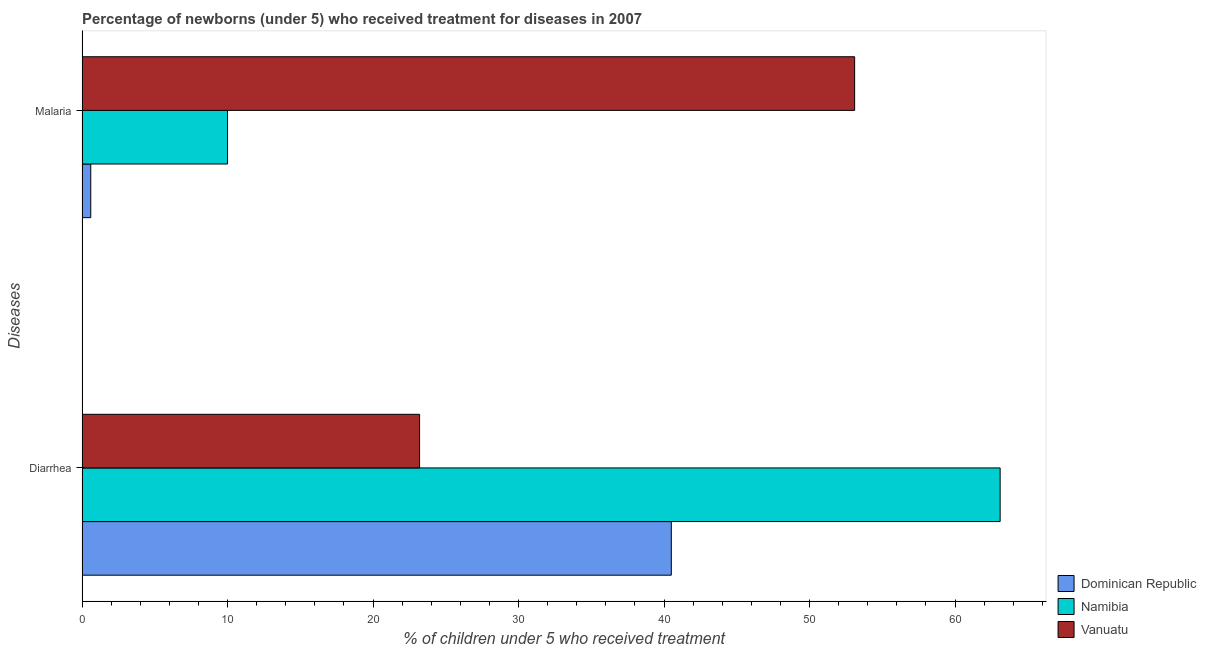How many different coloured bars are there?
Your answer should be compact. 3. Are the number of bars per tick equal to the number of legend labels?
Ensure brevity in your answer.  Yes. Are the number of bars on each tick of the Y-axis equal?
Give a very brief answer. Yes. How many bars are there on the 1st tick from the top?
Provide a short and direct response. 3. What is the label of the 1st group of bars from the top?
Provide a succinct answer. Malaria. Across all countries, what is the maximum percentage of children who received treatment for diarrhoea?
Your answer should be very brief. 63.1. Across all countries, what is the minimum percentage of children who received treatment for malaria?
Give a very brief answer. 0.6. In which country was the percentage of children who received treatment for malaria maximum?
Make the answer very short. Vanuatu. In which country was the percentage of children who received treatment for malaria minimum?
Offer a very short reply. Dominican Republic. What is the total percentage of children who received treatment for diarrhoea in the graph?
Your answer should be very brief. 126.8. What is the difference between the percentage of children who received treatment for diarrhoea in Dominican Republic and that in Vanuatu?
Give a very brief answer. 17.3. What is the difference between the percentage of children who received treatment for malaria in Namibia and the percentage of children who received treatment for diarrhoea in Vanuatu?
Provide a succinct answer. -13.2. What is the average percentage of children who received treatment for malaria per country?
Keep it short and to the point. 21.23. What is the difference between the percentage of children who received treatment for diarrhoea and percentage of children who received treatment for malaria in Vanuatu?
Provide a short and direct response. -29.9. In how many countries, is the percentage of children who received treatment for diarrhoea greater than 24 %?
Keep it short and to the point. 2. What is the ratio of the percentage of children who received treatment for diarrhoea in Vanuatu to that in Namibia?
Your response must be concise. 0.37. What does the 2nd bar from the top in Malaria represents?
Keep it short and to the point. Namibia. What does the 2nd bar from the bottom in Diarrhea represents?
Offer a very short reply. Namibia. How many countries are there in the graph?
Offer a very short reply. 3. Are the values on the major ticks of X-axis written in scientific E-notation?
Keep it short and to the point. No. Does the graph contain any zero values?
Offer a very short reply. No. Does the graph contain grids?
Ensure brevity in your answer.  No. Where does the legend appear in the graph?
Your answer should be very brief. Bottom right. How many legend labels are there?
Keep it short and to the point. 3. What is the title of the graph?
Your response must be concise. Percentage of newborns (under 5) who received treatment for diseases in 2007. Does "Singapore" appear as one of the legend labels in the graph?
Your answer should be very brief. No. What is the label or title of the X-axis?
Provide a succinct answer. % of children under 5 who received treatment. What is the label or title of the Y-axis?
Your response must be concise. Diseases. What is the % of children under 5 who received treatment of Dominican Republic in Diarrhea?
Give a very brief answer. 40.5. What is the % of children under 5 who received treatment of Namibia in Diarrhea?
Your answer should be compact. 63.1. What is the % of children under 5 who received treatment of Vanuatu in Diarrhea?
Provide a succinct answer. 23.2. What is the % of children under 5 who received treatment in Vanuatu in Malaria?
Ensure brevity in your answer.  53.1. Across all Diseases, what is the maximum % of children under 5 who received treatment of Dominican Republic?
Your response must be concise. 40.5. Across all Diseases, what is the maximum % of children under 5 who received treatment of Namibia?
Offer a very short reply. 63.1. Across all Diseases, what is the maximum % of children under 5 who received treatment in Vanuatu?
Ensure brevity in your answer.  53.1. Across all Diseases, what is the minimum % of children under 5 who received treatment of Dominican Republic?
Provide a succinct answer. 0.6. Across all Diseases, what is the minimum % of children under 5 who received treatment of Namibia?
Provide a short and direct response. 10. Across all Diseases, what is the minimum % of children under 5 who received treatment of Vanuatu?
Offer a very short reply. 23.2. What is the total % of children under 5 who received treatment in Dominican Republic in the graph?
Make the answer very short. 41.1. What is the total % of children under 5 who received treatment of Namibia in the graph?
Your answer should be compact. 73.1. What is the total % of children under 5 who received treatment of Vanuatu in the graph?
Offer a terse response. 76.3. What is the difference between the % of children under 5 who received treatment in Dominican Republic in Diarrhea and that in Malaria?
Offer a terse response. 39.9. What is the difference between the % of children under 5 who received treatment of Namibia in Diarrhea and that in Malaria?
Your answer should be very brief. 53.1. What is the difference between the % of children under 5 who received treatment of Vanuatu in Diarrhea and that in Malaria?
Your answer should be very brief. -29.9. What is the difference between the % of children under 5 who received treatment in Dominican Republic in Diarrhea and the % of children under 5 who received treatment in Namibia in Malaria?
Keep it short and to the point. 30.5. What is the difference between the % of children under 5 who received treatment in Dominican Republic in Diarrhea and the % of children under 5 who received treatment in Vanuatu in Malaria?
Your answer should be very brief. -12.6. What is the difference between the % of children under 5 who received treatment of Namibia in Diarrhea and the % of children under 5 who received treatment of Vanuatu in Malaria?
Your answer should be compact. 10. What is the average % of children under 5 who received treatment in Dominican Republic per Diseases?
Ensure brevity in your answer.  20.55. What is the average % of children under 5 who received treatment in Namibia per Diseases?
Make the answer very short. 36.55. What is the average % of children under 5 who received treatment of Vanuatu per Diseases?
Your answer should be compact. 38.15. What is the difference between the % of children under 5 who received treatment in Dominican Republic and % of children under 5 who received treatment in Namibia in Diarrhea?
Offer a terse response. -22.6. What is the difference between the % of children under 5 who received treatment of Namibia and % of children under 5 who received treatment of Vanuatu in Diarrhea?
Your response must be concise. 39.9. What is the difference between the % of children under 5 who received treatment of Dominican Republic and % of children under 5 who received treatment of Namibia in Malaria?
Your response must be concise. -9.4. What is the difference between the % of children under 5 who received treatment in Dominican Republic and % of children under 5 who received treatment in Vanuatu in Malaria?
Offer a very short reply. -52.5. What is the difference between the % of children under 5 who received treatment of Namibia and % of children under 5 who received treatment of Vanuatu in Malaria?
Offer a terse response. -43.1. What is the ratio of the % of children under 5 who received treatment in Dominican Republic in Diarrhea to that in Malaria?
Your answer should be very brief. 67.5. What is the ratio of the % of children under 5 who received treatment of Namibia in Diarrhea to that in Malaria?
Offer a terse response. 6.31. What is the ratio of the % of children under 5 who received treatment of Vanuatu in Diarrhea to that in Malaria?
Your answer should be compact. 0.44. What is the difference between the highest and the second highest % of children under 5 who received treatment of Dominican Republic?
Give a very brief answer. 39.9. What is the difference between the highest and the second highest % of children under 5 who received treatment in Namibia?
Give a very brief answer. 53.1. What is the difference between the highest and the second highest % of children under 5 who received treatment of Vanuatu?
Make the answer very short. 29.9. What is the difference between the highest and the lowest % of children under 5 who received treatment in Dominican Republic?
Provide a succinct answer. 39.9. What is the difference between the highest and the lowest % of children under 5 who received treatment in Namibia?
Give a very brief answer. 53.1. What is the difference between the highest and the lowest % of children under 5 who received treatment of Vanuatu?
Keep it short and to the point. 29.9. 